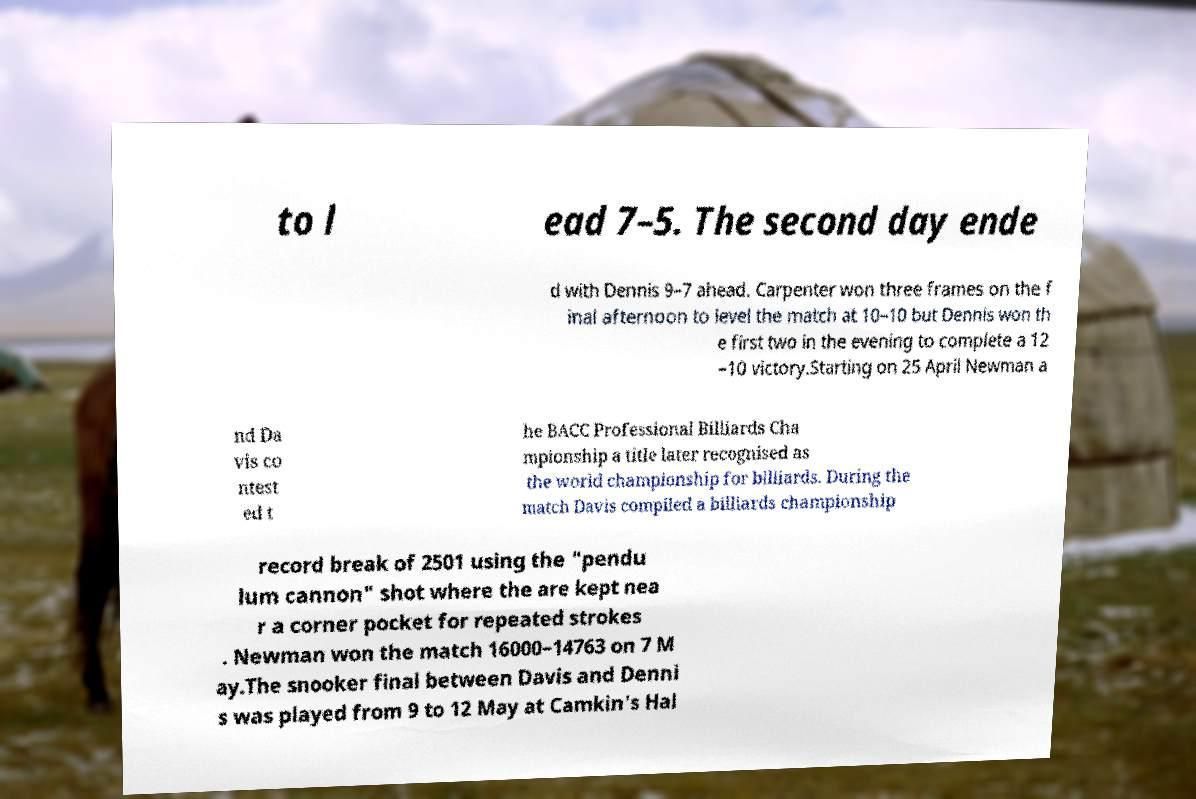For documentation purposes, I need the text within this image transcribed. Could you provide that? to l ead 7–5. The second day ende d with Dennis 9–7 ahead. Carpenter won three frames on the f inal afternoon to level the match at 10–10 but Dennis won th e first two in the evening to complete a 12 –10 victory.Starting on 25 April Newman a nd Da vis co ntest ed t he BACC Professional Billiards Cha mpionship a title later recognised as the world championship for billiards. During the match Davis compiled a billiards championship record break of 2501 using the "pendu lum cannon" shot where the are kept nea r a corner pocket for repeated strokes . Newman won the match 16000–14763 on 7 M ay.The snooker final between Davis and Denni s was played from 9 to 12 May at Camkin's Hal 